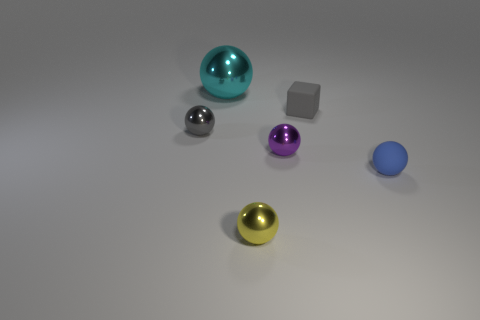Are there any other tiny blue things that have the same shape as the blue matte object?
Your response must be concise. No. There is another rubber object that is the same size as the gray matte object; what shape is it?
Offer a very short reply. Sphere. There is a tiny ball that is in front of the small sphere right of the tiny gray thing that is on the right side of the cyan sphere; what is its material?
Offer a very short reply. Metal. Is the size of the blue rubber thing the same as the gray shiny ball?
Provide a succinct answer. Yes. What is the big thing made of?
Offer a terse response. Metal. There is a tiny ball that is the same color as the tiny block; what is it made of?
Make the answer very short. Metal. There is a tiny thing that is to the left of the tiny yellow metal object; does it have the same shape as the gray matte thing?
Ensure brevity in your answer.  No. How many things are either gray balls or large things?
Keep it short and to the point. 2. Do the sphere that is in front of the small blue ball and the large ball have the same material?
Offer a very short reply. Yes. How big is the gray ball?
Provide a succinct answer. Small. 